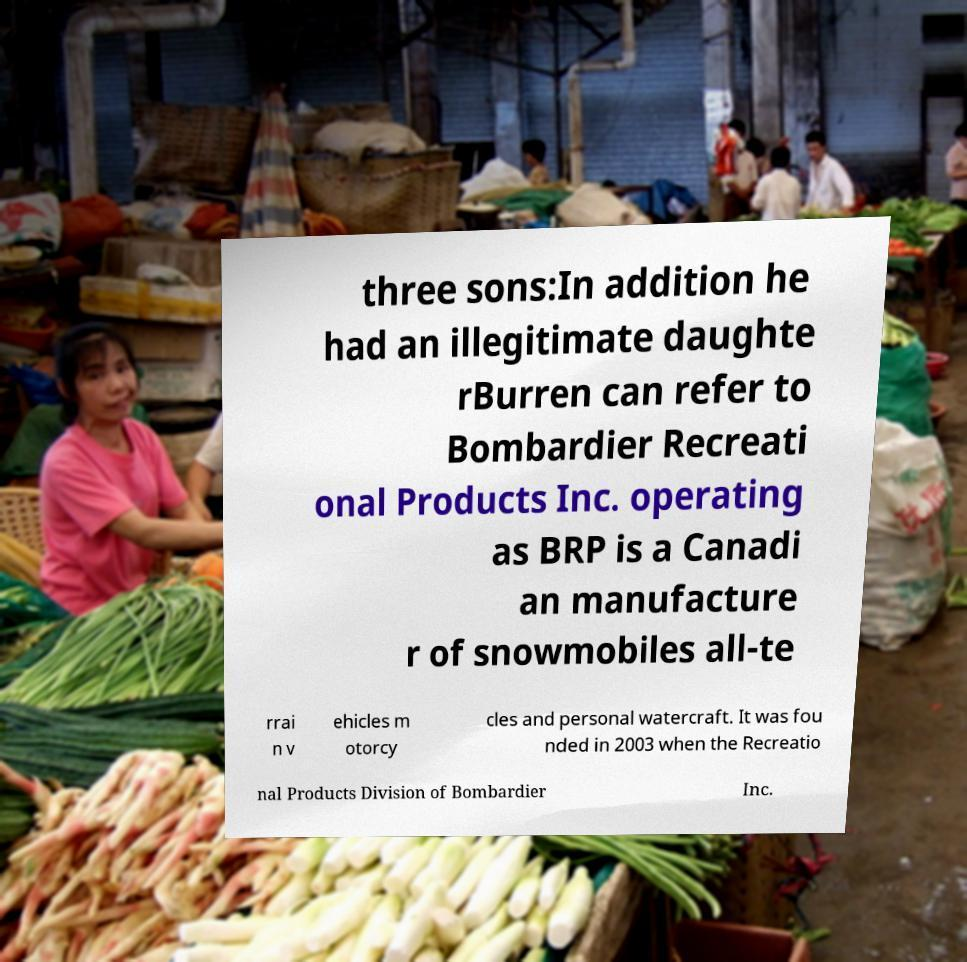For documentation purposes, I need the text within this image transcribed. Could you provide that? three sons:In addition he had an illegitimate daughte rBurren can refer to Bombardier Recreati onal Products Inc. operating as BRP is a Canadi an manufacture r of snowmobiles all-te rrai n v ehicles m otorcy cles and personal watercraft. It was fou nded in 2003 when the Recreatio nal Products Division of Bombardier Inc. 